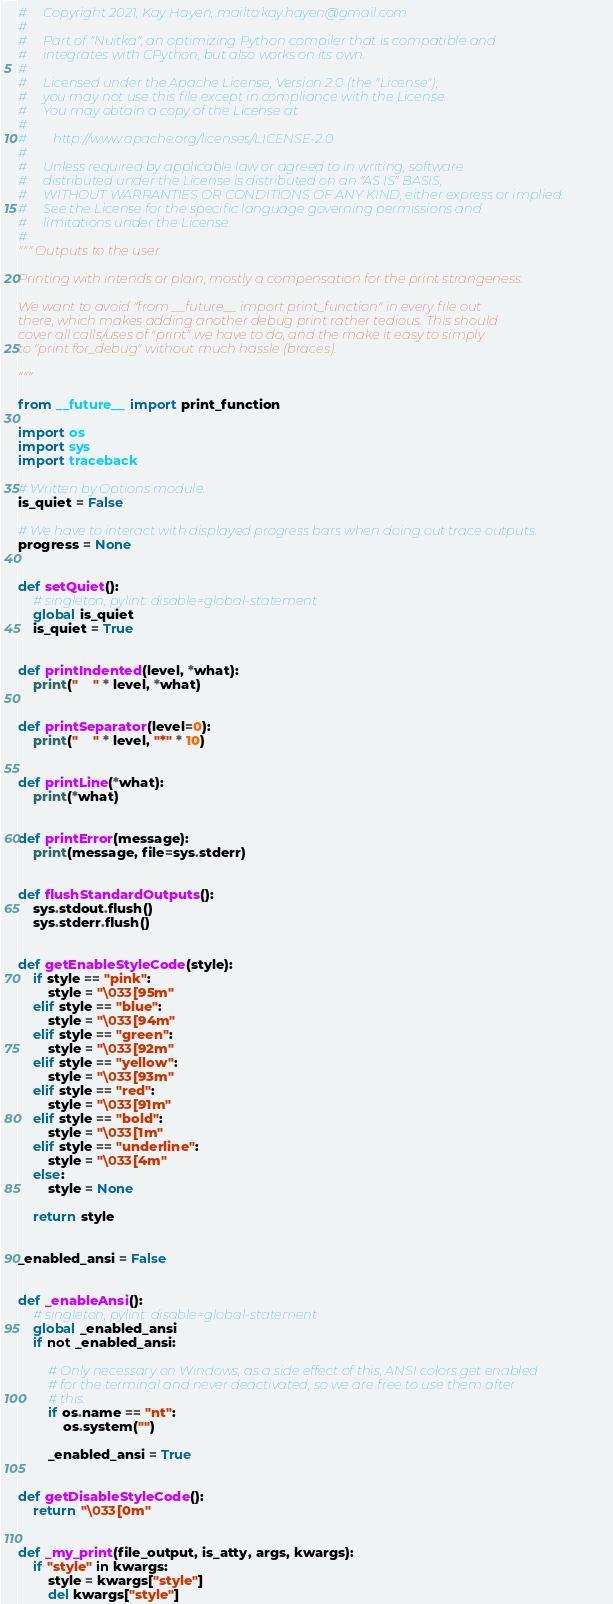Convert code to text. <code><loc_0><loc_0><loc_500><loc_500><_Python_>#     Copyright 2021, Kay Hayen, mailto:kay.hayen@gmail.com
#
#     Part of "Nuitka", an optimizing Python compiler that is compatible and
#     integrates with CPython, but also works on its own.
#
#     Licensed under the Apache License, Version 2.0 (the "License");
#     you may not use this file except in compliance with the License.
#     You may obtain a copy of the License at
#
#        http://www.apache.org/licenses/LICENSE-2.0
#
#     Unless required by applicable law or agreed to in writing, software
#     distributed under the License is distributed on an "AS IS" BASIS,
#     WITHOUT WARRANTIES OR CONDITIONS OF ANY KIND, either express or implied.
#     See the License for the specific language governing permissions and
#     limitations under the License.
#
""" Outputs to the user.

Printing with intends or plain, mostly a compensation for the print strangeness.

We want to avoid "from __future__ import print_function" in every file out
there, which makes adding another debug print rather tedious. This should
cover all calls/uses of "print" we have to do, and the make it easy to simply
to "print for_debug" without much hassle (braces).

"""

from __future__ import print_function

import os
import sys
import traceback

# Written by Options module.
is_quiet = False

# We have to interact with displayed progress bars when doing out trace outputs.
progress = None


def setQuiet():
    # singleton, pylint: disable=global-statement
    global is_quiet
    is_quiet = True


def printIndented(level, *what):
    print("    " * level, *what)


def printSeparator(level=0):
    print("    " * level, "*" * 10)


def printLine(*what):
    print(*what)


def printError(message):
    print(message, file=sys.stderr)


def flushStandardOutputs():
    sys.stdout.flush()
    sys.stderr.flush()


def getEnableStyleCode(style):
    if style == "pink":
        style = "\033[95m"
    elif style == "blue":
        style = "\033[94m"
    elif style == "green":
        style = "\033[92m"
    elif style == "yellow":
        style = "\033[93m"
    elif style == "red":
        style = "\033[91m"
    elif style == "bold":
        style = "\033[1m"
    elif style == "underline":
        style = "\033[4m"
    else:
        style = None

    return style


_enabled_ansi = False


def _enableAnsi():
    # singleton, pylint: disable=global-statement
    global _enabled_ansi
    if not _enabled_ansi:

        # Only necessary on Windows, as a side effect of this, ANSI colors get enabled
        # for the terminal and never deactivated, so we are free to use them after
        # this.
        if os.name == "nt":
            os.system("")

        _enabled_ansi = True


def getDisableStyleCode():
    return "\033[0m"


def _my_print(file_output, is_atty, args, kwargs):
    if "style" in kwargs:
        style = kwargs["style"]
        del kwargs["style"]
</code> 